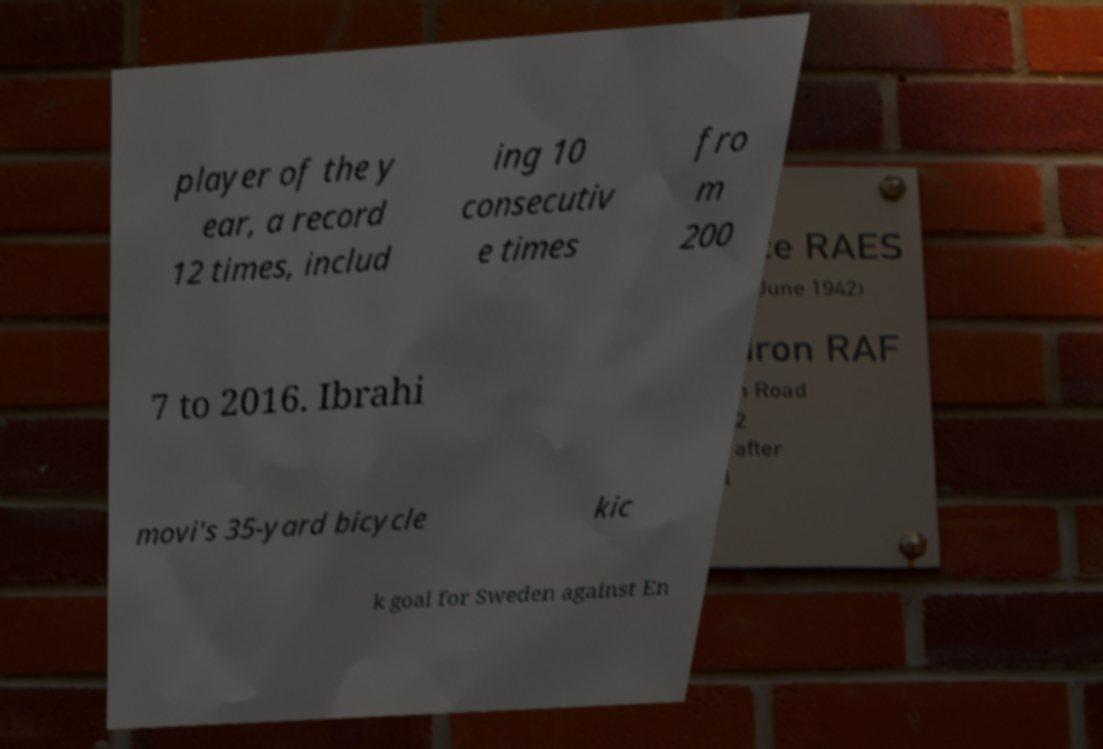There's text embedded in this image that I need extracted. Can you transcribe it verbatim? player of the y ear, a record 12 times, includ ing 10 consecutiv e times fro m 200 7 to 2016. Ibrahi movi's 35-yard bicycle kic k goal for Sweden against En 